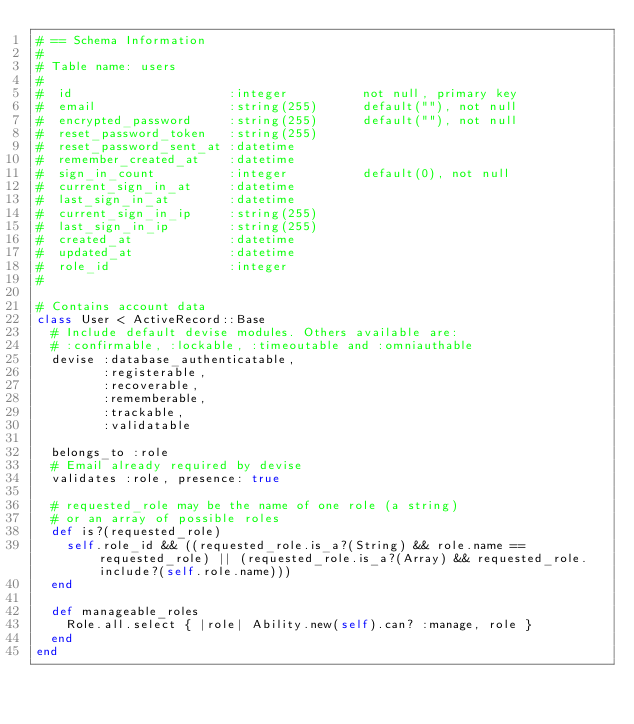<code> <loc_0><loc_0><loc_500><loc_500><_Ruby_># == Schema Information
#
# Table name: users
#
#  id                     :integer          not null, primary key
#  email                  :string(255)      default(""), not null
#  encrypted_password     :string(255)      default(""), not null
#  reset_password_token   :string(255)
#  reset_password_sent_at :datetime
#  remember_created_at    :datetime
#  sign_in_count          :integer          default(0), not null
#  current_sign_in_at     :datetime
#  last_sign_in_at        :datetime
#  current_sign_in_ip     :string(255)
#  last_sign_in_ip        :string(255)
#  created_at             :datetime
#  updated_at             :datetime
#  role_id                :integer
#

# Contains account data
class User < ActiveRecord::Base
  # Include default devise modules. Others available are:
  # :confirmable, :lockable, :timeoutable and :omniauthable
  devise :database_authenticatable,
         :registerable,
         :recoverable,
         :rememberable,
         :trackable,
         :validatable

  belongs_to :role
  # Email already required by devise
  validates :role, presence: true

  # requested_role may be the name of one role (a string)
  # or an array of possible roles
  def is?(requested_role)
    self.role_id && ((requested_role.is_a?(String) && role.name == requested_role) || (requested_role.is_a?(Array) && requested_role.include?(self.role.name)))
  end

  def manageable_roles
    Role.all.select { |role| Ability.new(self).can? :manage, role }
  end
end
</code> 